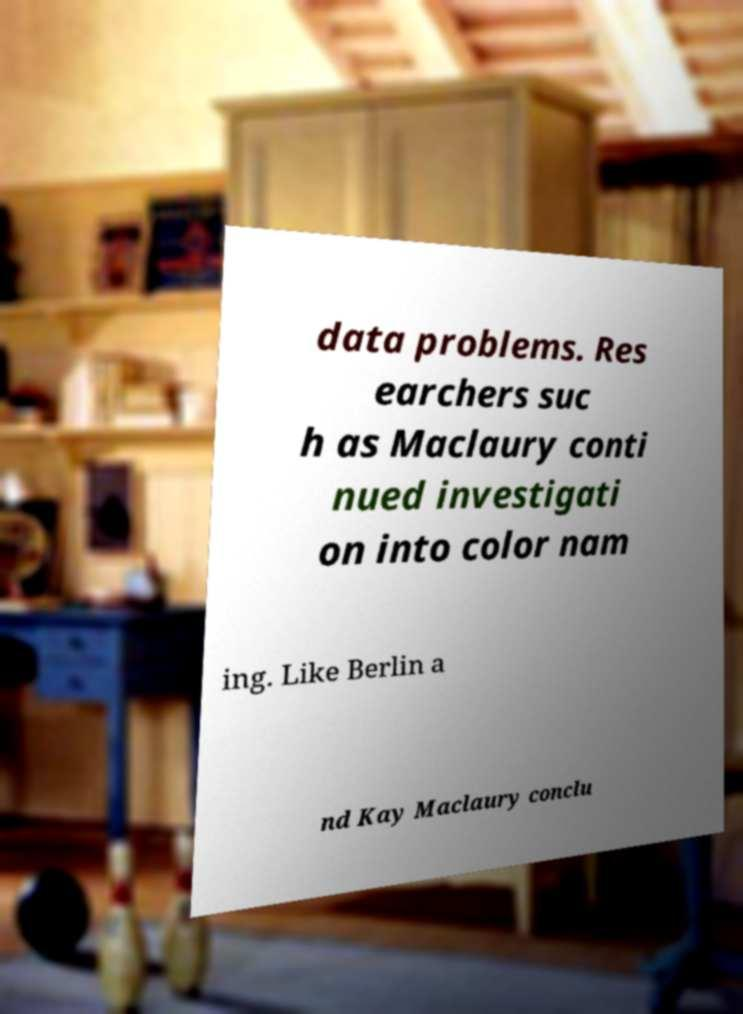Could you extract and type out the text from this image? data problems. Res earchers suc h as Maclaury conti nued investigati on into color nam ing. Like Berlin a nd Kay Maclaury conclu 